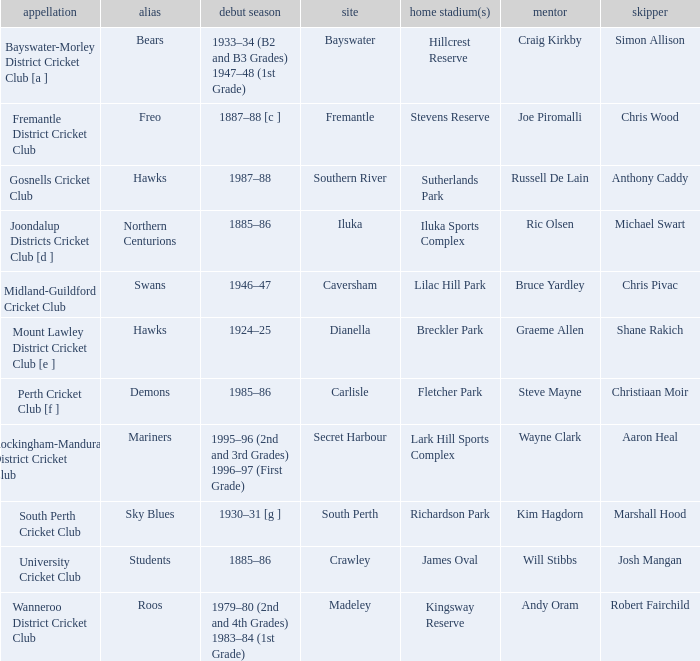What is the code nickname where Steve Mayne is the coach? Demons. 